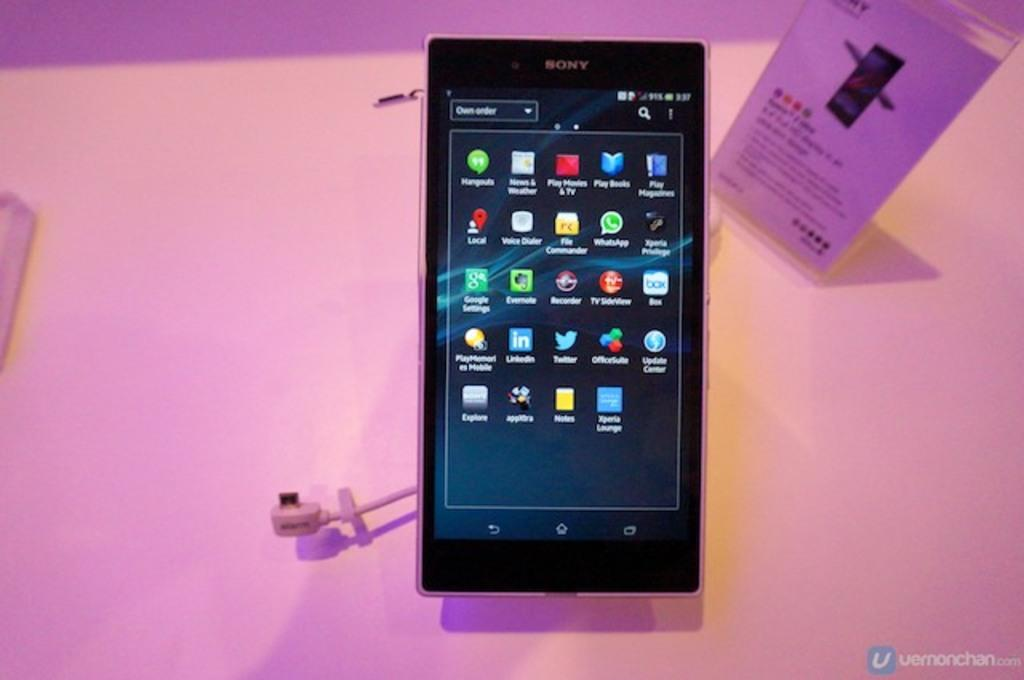<image>
Write a terse but informative summary of the picture. a Sony cell phone is in a dimly lit display case 